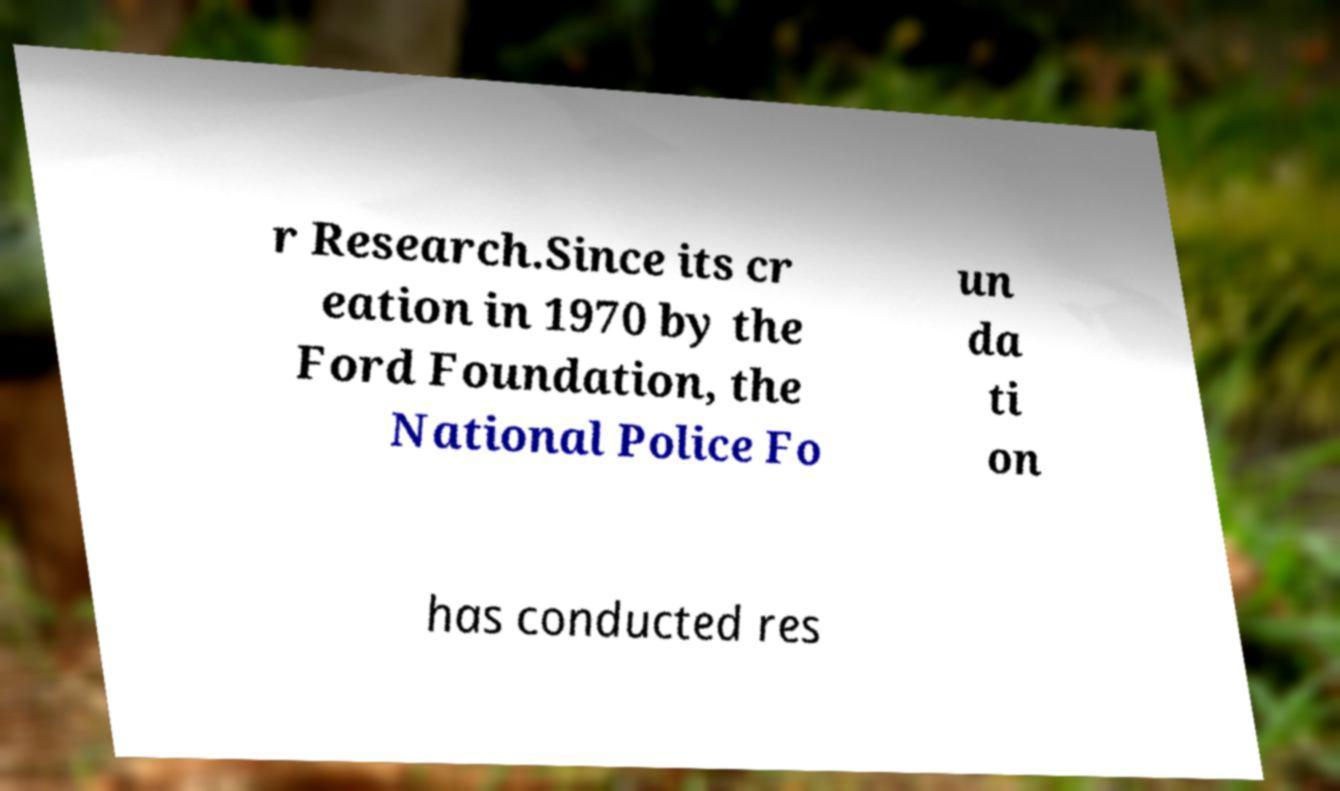What messages or text are displayed in this image? I need them in a readable, typed format. r Research.Since its cr eation in 1970 by the Ford Foundation, the National Police Fo un da ti on has conducted res 